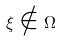Convert formula to latex. <formula><loc_0><loc_0><loc_500><loc_500>\xi \notin \Omega</formula> 